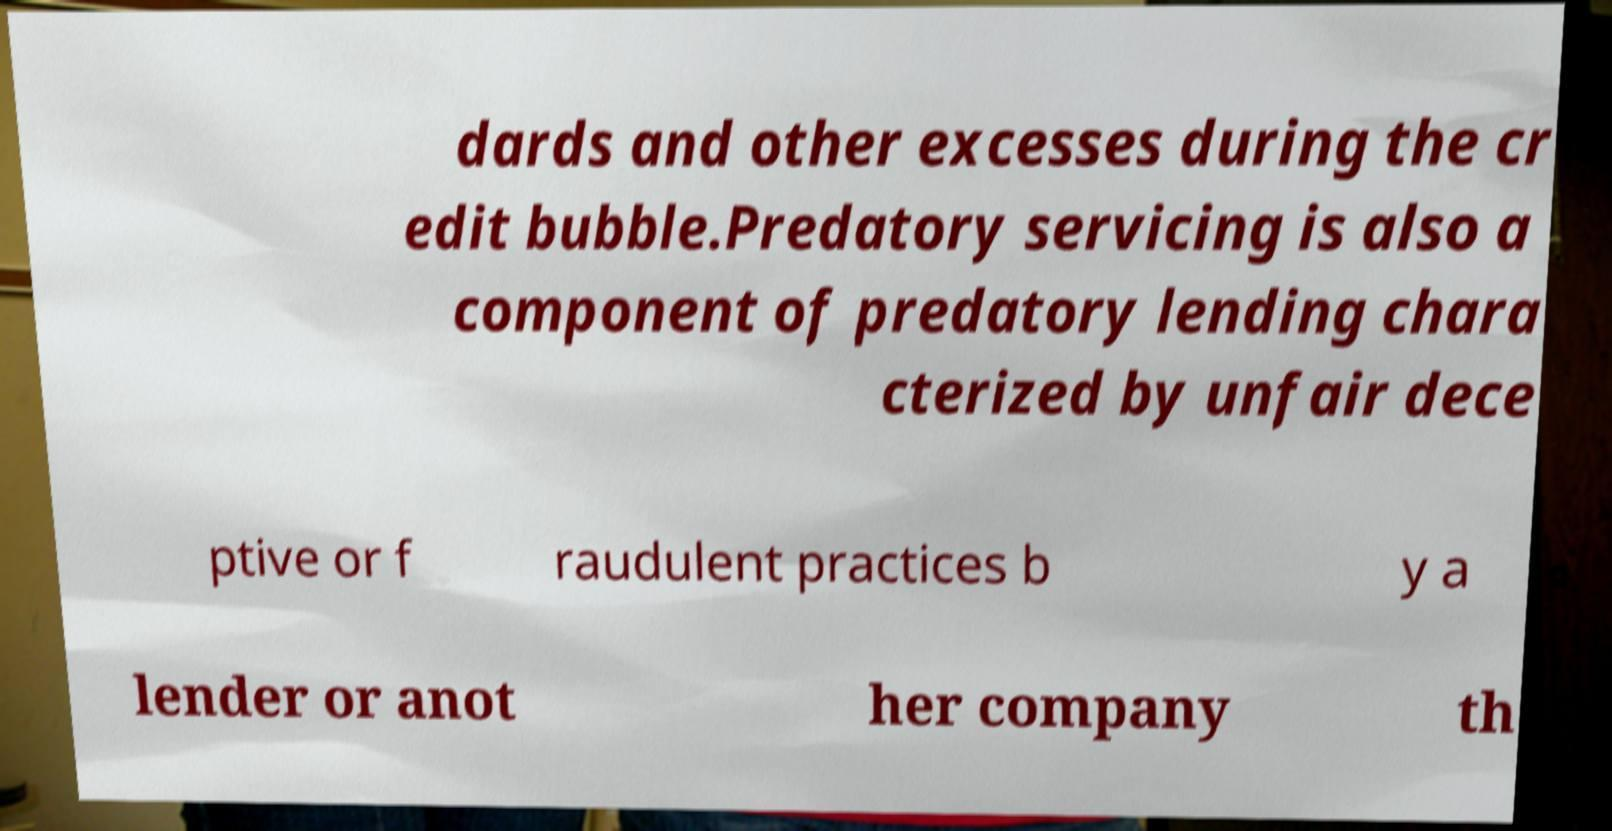Could you extract and type out the text from this image? dards and other excesses during the cr edit bubble.Predatory servicing is also a component of predatory lending chara cterized by unfair dece ptive or f raudulent practices b y a lender or anot her company th 